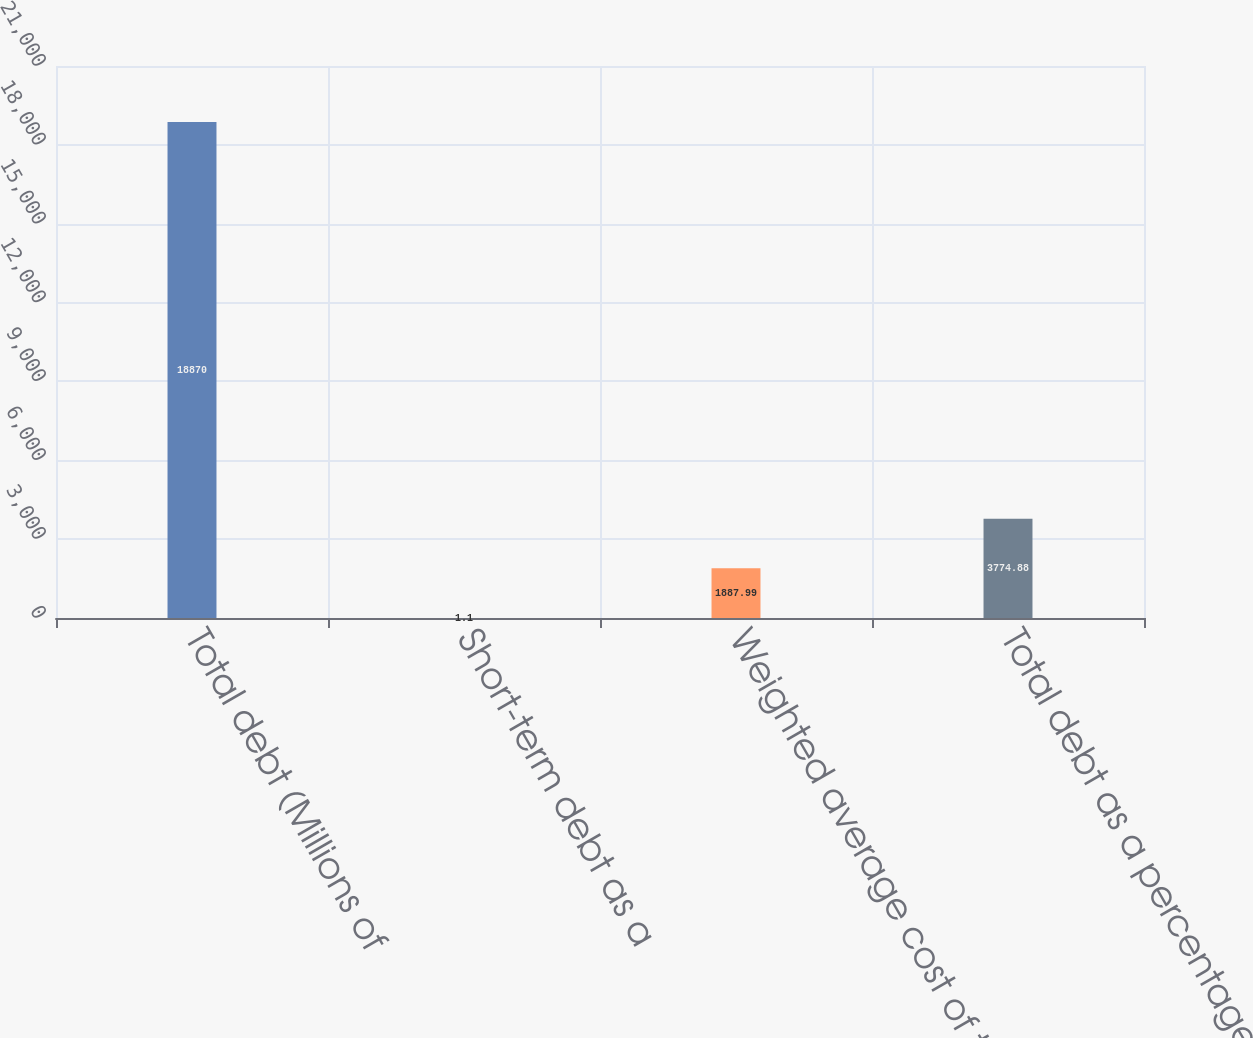Convert chart. <chart><loc_0><loc_0><loc_500><loc_500><bar_chart><fcel>Total debt (Millions of<fcel>Short-term debt as a<fcel>Weighted average cost of total<fcel>Total debt as a percentage of<nl><fcel>18870<fcel>1.1<fcel>1887.99<fcel>3774.88<nl></chart> 